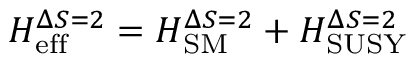Convert formula to latex. <formula><loc_0><loc_0><loc_500><loc_500>H _ { e f f } ^ { \Delta S = 2 } = H _ { S M } ^ { \Delta S = 2 } + H _ { S U S Y } ^ { \Delta S = 2 }</formula> 